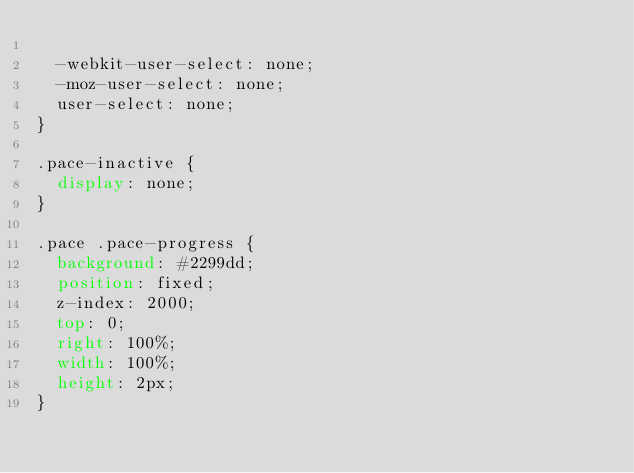Convert code to text. <code><loc_0><loc_0><loc_500><loc_500><_CSS_>
  -webkit-user-select: none;
  -moz-user-select: none;
  user-select: none;
}

.pace-inactive {
  display: none;
}

.pace .pace-progress {
  background: #2299dd;
  position: fixed;
  z-index: 2000;
  top: 0;
  right: 100%;
  width: 100%;
  height: 2px;
}
</code> 